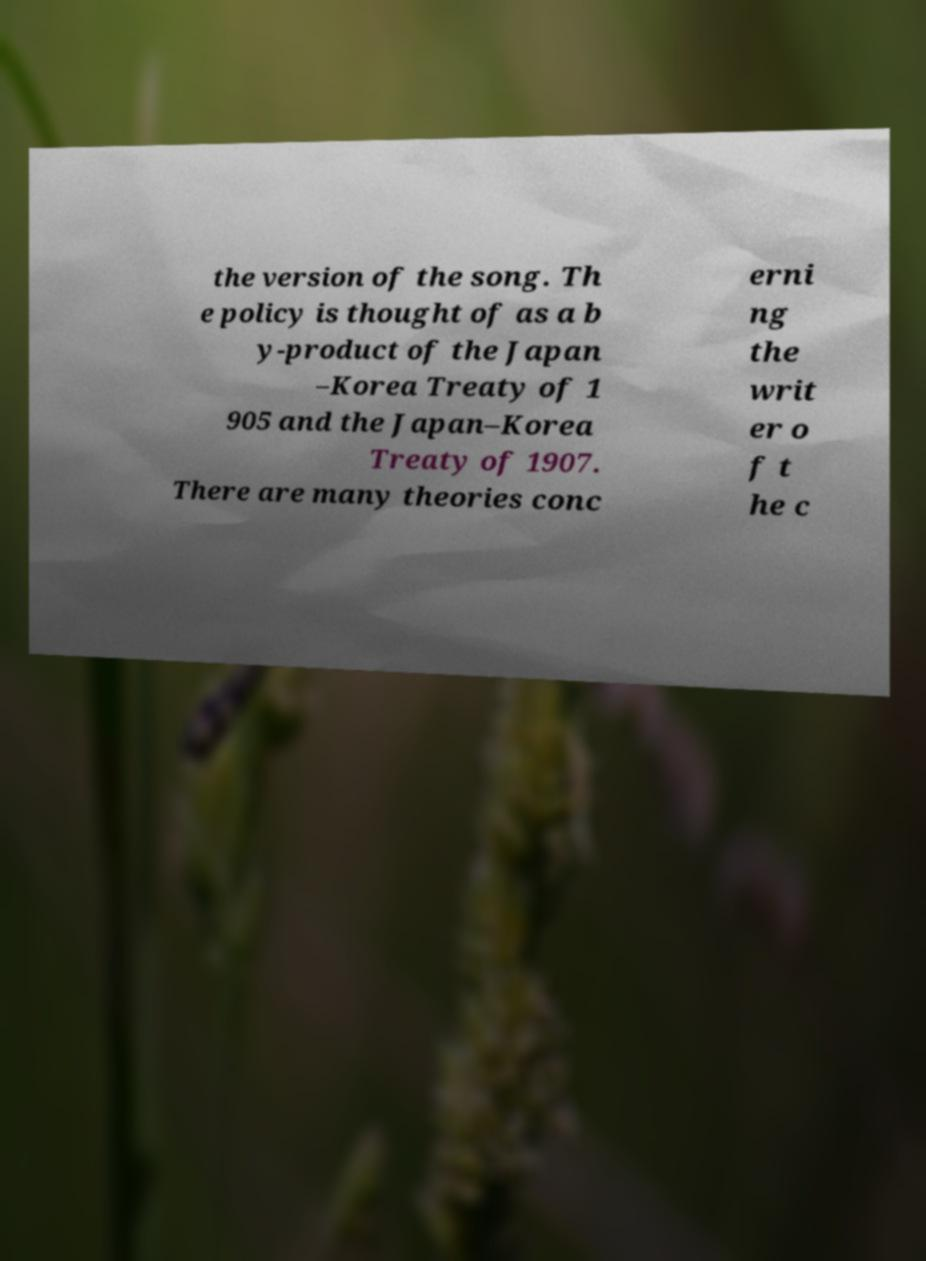There's text embedded in this image that I need extracted. Can you transcribe it verbatim? the version of the song. Th e policy is thought of as a b y-product of the Japan –Korea Treaty of 1 905 and the Japan–Korea Treaty of 1907. There are many theories conc erni ng the writ er o f t he c 